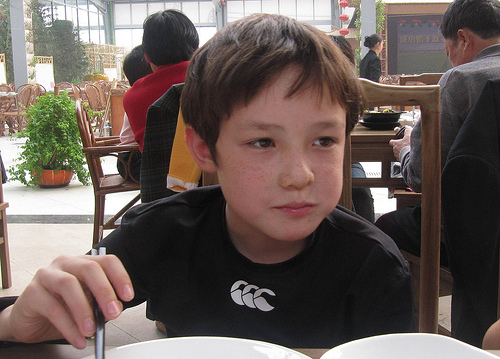<image>
Can you confirm if the green plant is next to the boy? No. The green plant is not positioned next to the boy. They are located in different areas of the scene. 